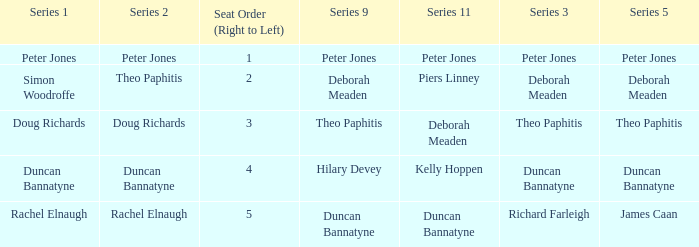How many Seat Orders (Right to Left) have a Series 3 of deborah meaden? 1.0. 